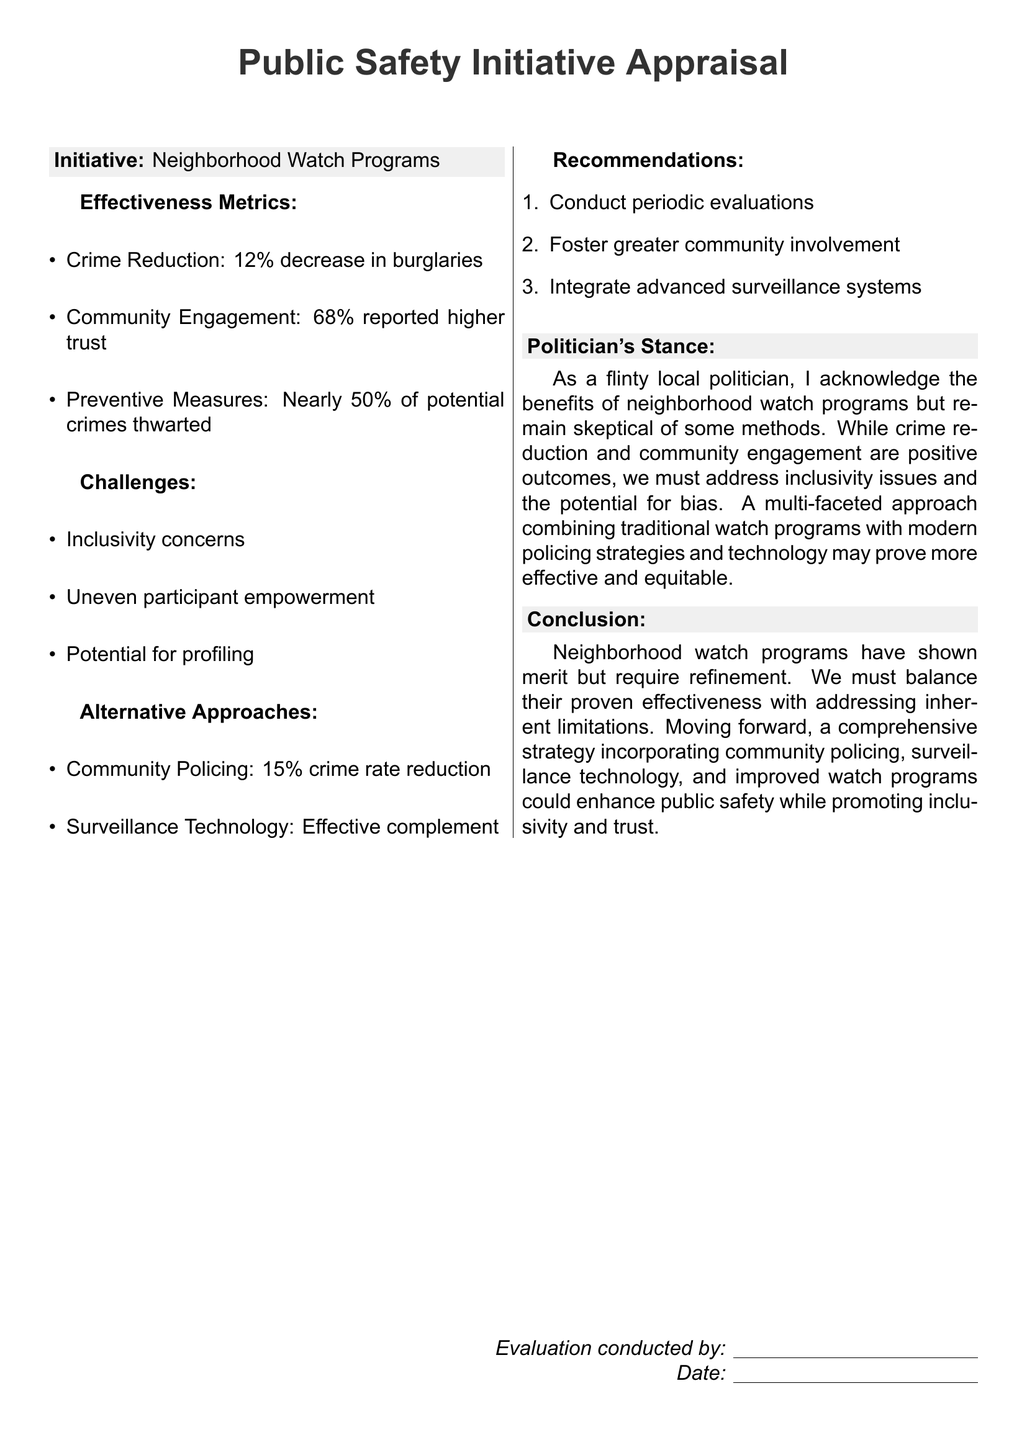What is the name of the initiative being appraised? The initiative being appraised is specifically identified as "Neighborhood Watch Programs" in the document.
Answer: Neighborhood Watch Programs What percentage decrease in burglaries is reported? The document states that there is a "12% decrease in burglaries" as a metric of effectiveness.
Answer: 12% What percentage of participants reported higher trust? The appraisal indicates that "68% reported higher trust" among community members.
Answer: 68% What are the inclusivity concerns mentioned? The document lists "Inclusivity concerns" as a challenge regarding the neighborhood watch initiative.
Answer: Inclusivity concerns What is one of the alternative approaches discussed? The document mentions "Community Policing" as one of the alternative approaches, along with its effectiveness in crime reduction.
Answer: Community Policing What is the suggested action for improving engagement? The recommendation includes the action to "Foster greater community involvement" to enhance engagement in the program.
Answer: Foster greater community involvement What is the politician's general stance on neighborhood watch programs? The politician acknowledges the benefits but expresses skepticism regarding certain methods used, particularly concerning inclusivity and bias.
Answer: Skeptical of some methods What is the conclusion regarding neighborhood watch programs? The conclusion emphasizes that neighborhood watch programs "have shown merit but require refinement" for greater effectiveness and inclusivity.
Answer: Require refinement 